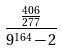<formula> <loc_0><loc_0><loc_500><loc_500>\frac { \frac { 4 0 6 } { 2 7 7 } } { 9 ^ { 1 6 4 } - 2 }</formula> 